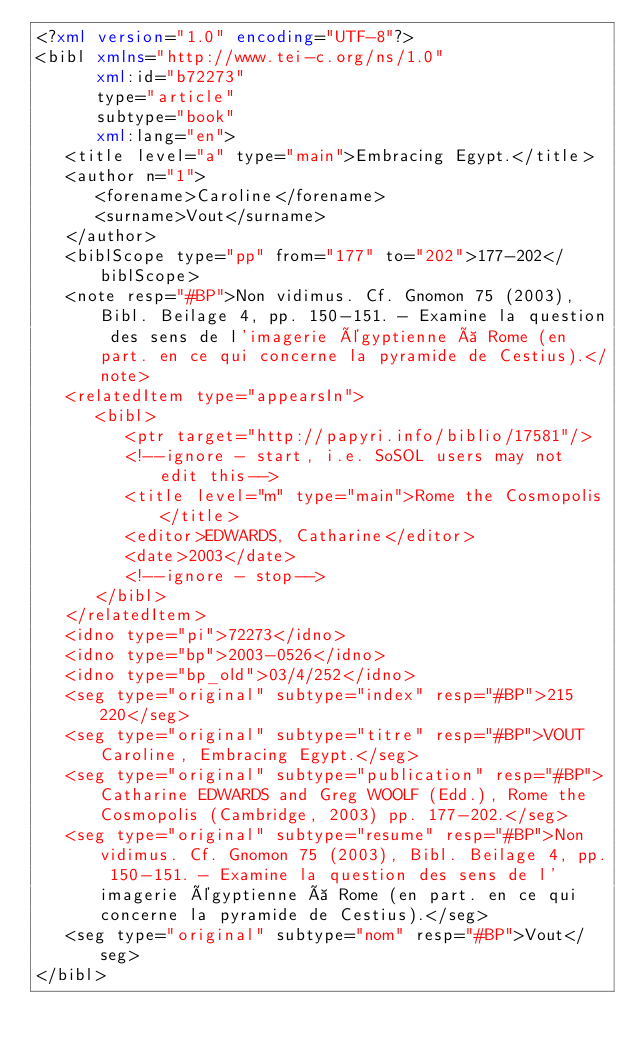<code> <loc_0><loc_0><loc_500><loc_500><_XML_><?xml version="1.0" encoding="UTF-8"?>
<bibl xmlns="http://www.tei-c.org/ns/1.0"
      xml:id="b72273"
      type="article"
      subtype="book"
      xml:lang="en">
   <title level="a" type="main">Embracing Egypt.</title>
   <author n="1">
      <forename>Caroline</forename>
      <surname>Vout</surname>
   </author>
   <biblScope type="pp" from="177" to="202">177-202</biblScope>
   <note resp="#BP">Non vidimus. Cf. Gnomon 75 (2003), Bibl. Beilage 4, pp. 150-151. - Examine la question des sens de l'imagerie égyptienne à Rome (en part. en ce qui concerne la pyramide de Cestius).</note>
   <relatedItem type="appearsIn">
      <bibl>
         <ptr target="http://papyri.info/biblio/17581"/>
         <!--ignore - start, i.e. SoSOL users may not edit this-->
         <title level="m" type="main">Rome the Cosmopolis</title>
         <editor>EDWARDS, Catharine</editor>
         <date>2003</date>
         <!--ignore - stop-->
      </bibl>
   </relatedItem>
   <idno type="pi">72273</idno>
   <idno type="bp">2003-0526</idno>
   <idno type="bp_old">03/4/252</idno>
   <seg type="original" subtype="index" resp="#BP">215 220</seg>
   <seg type="original" subtype="titre" resp="#BP">VOUT Caroline, Embracing Egypt.</seg>
   <seg type="original" subtype="publication" resp="#BP">Catharine EDWARDS and Greg WOOLF (Edd.), Rome the Cosmopolis (Cambridge, 2003) pp. 177-202.</seg>
   <seg type="original" subtype="resume" resp="#BP">Non vidimus. Cf. Gnomon 75 (2003), Bibl. Beilage 4, pp. 150-151. - Examine la question des sens de l'imagerie égyptienne à Rome (en part. en ce qui concerne la pyramide de Cestius).</seg>
   <seg type="original" subtype="nom" resp="#BP">Vout</seg>
</bibl>
</code> 